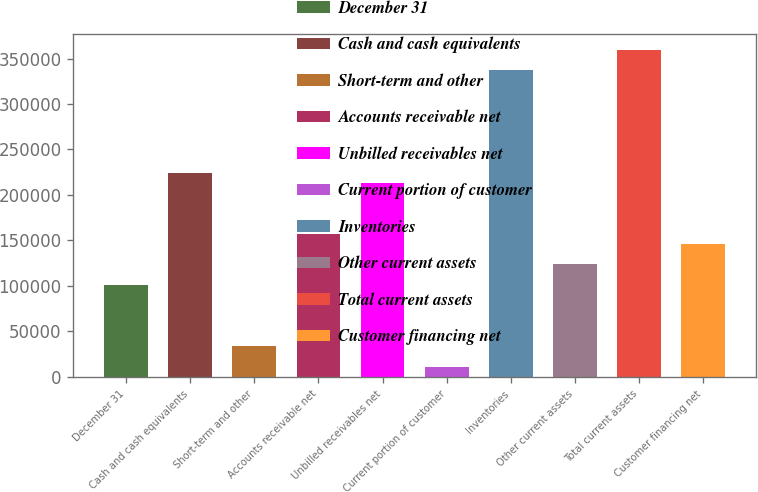<chart> <loc_0><loc_0><loc_500><loc_500><bar_chart><fcel>December 31<fcel>Cash and cash equivalents<fcel>Short-term and other<fcel>Accounts receivable net<fcel>Unbilled receivables net<fcel>Current portion of customer<fcel>Inventories<fcel>Other current assets<fcel>Total current assets<fcel>Customer financing net<nl><fcel>101132<fcel>224667<fcel>33748.5<fcel>157284<fcel>213436<fcel>11287.5<fcel>336972<fcel>123592<fcel>359433<fcel>146054<nl></chart> 